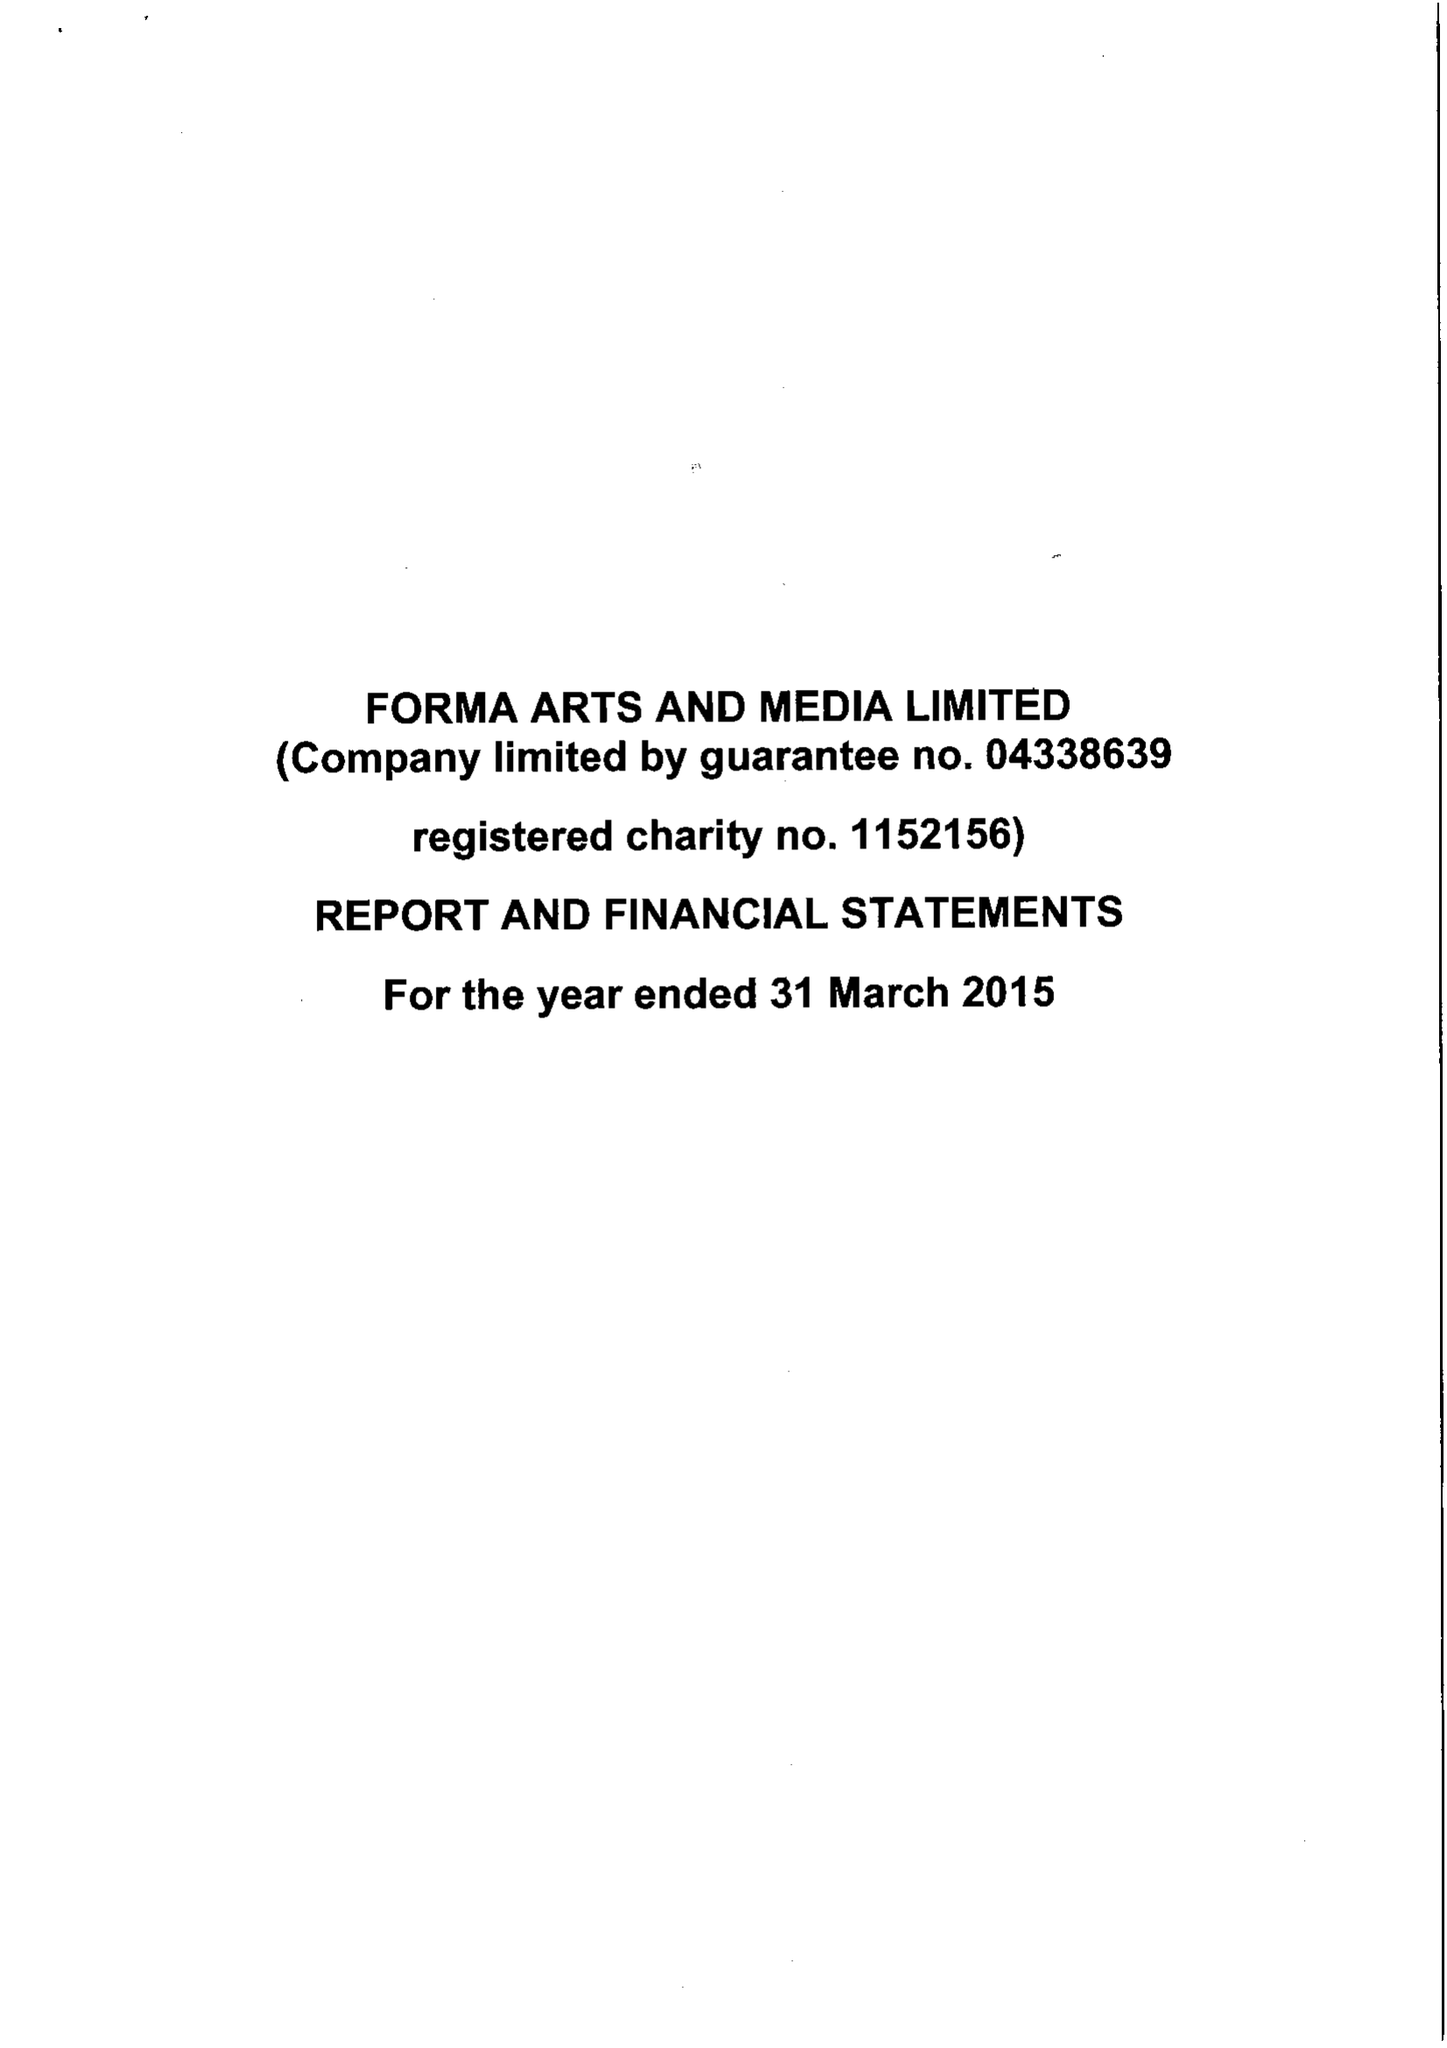What is the value for the address__postcode?
Answer the question using a single word or phrase. None 